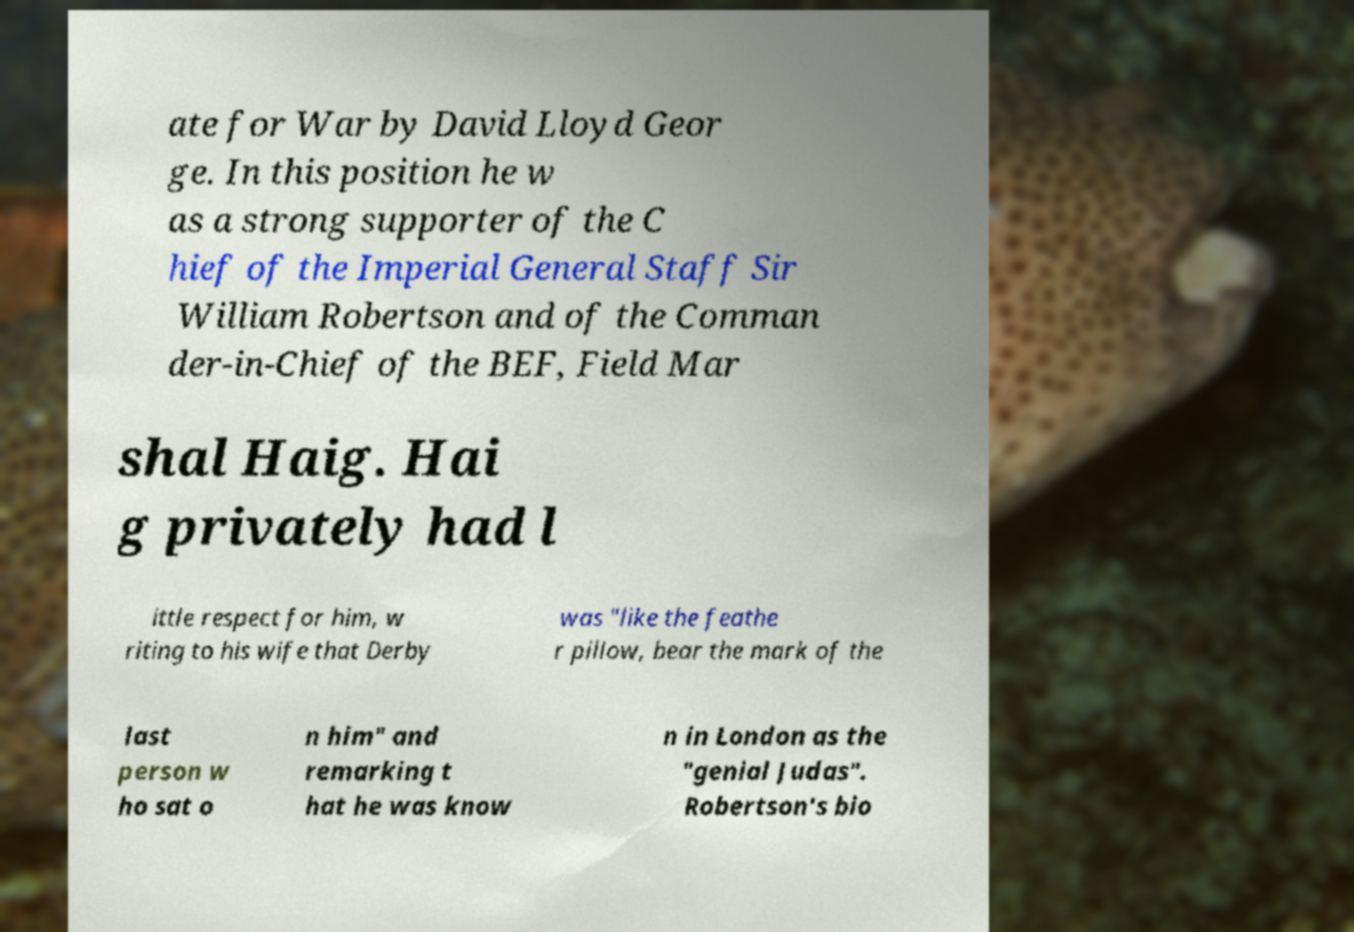Please identify and transcribe the text found in this image. ate for War by David Lloyd Geor ge. In this position he w as a strong supporter of the C hief of the Imperial General Staff Sir William Robertson and of the Comman der-in-Chief of the BEF, Field Mar shal Haig. Hai g privately had l ittle respect for him, w riting to his wife that Derby was "like the feathe r pillow, bear the mark of the last person w ho sat o n him" and remarking t hat he was know n in London as the "genial Judas". Robertson's bio 